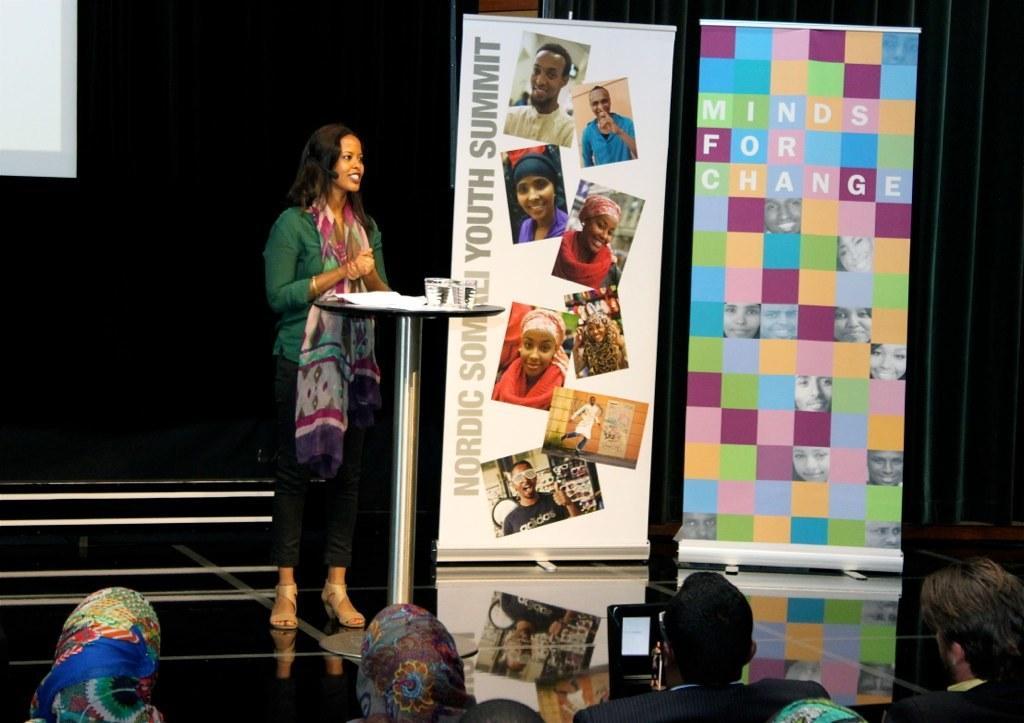Could you give a brief overview of what you see in this image? In the center of the image there is a person standing on the stage. In front of her there is a table and on top of the table there are glasses and papers. At the bottom of the image there are people. At the back side there is a black cloth. In front of that there are banners. 